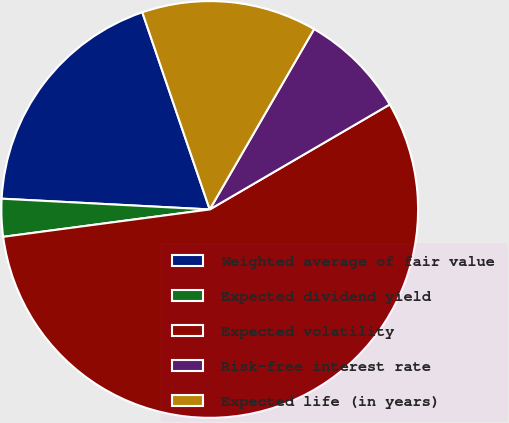Convert chart. <chart><loc_0><loc_0><loc_500><loc_500><pie_chart><fcel>Weighted average of fair value<fcel>Expected dividend yield<fcel>Expected volatility<fcel>Risk-free interest rate<fcel>Expected life (in years)<nl><fcel>18.93%<fcel>2.92%<fcel>56.3%<fcel>8.25%<fcel>13.59%<nl></chart> 